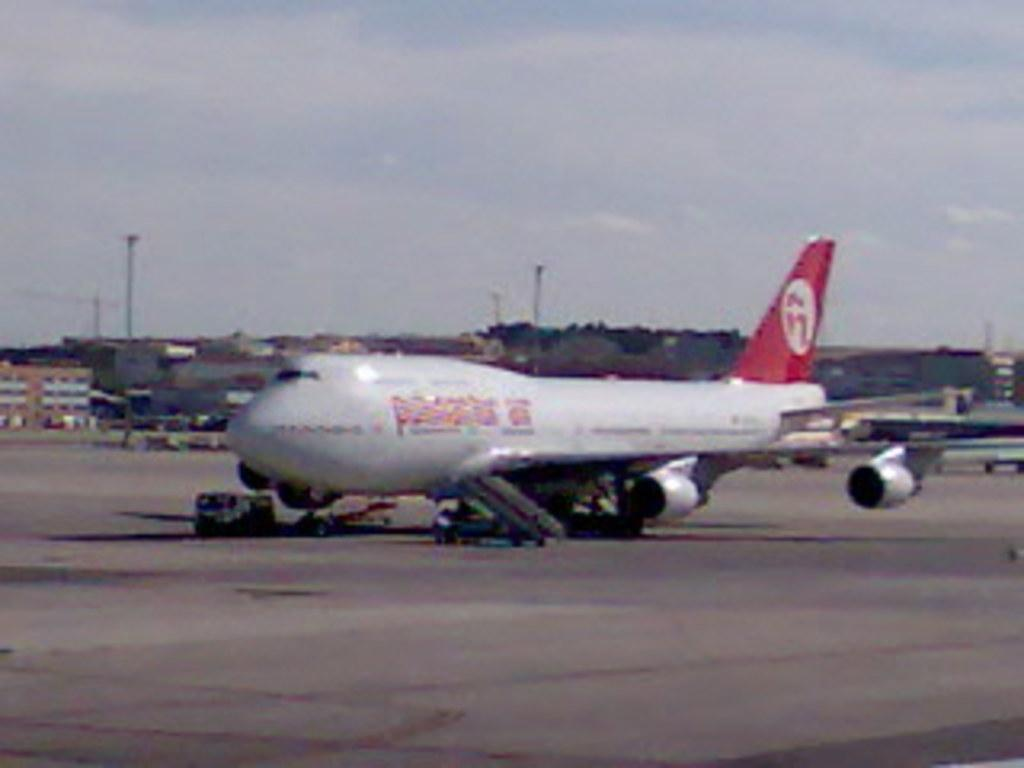What is the main subject of the image? The main subject of the image is an aircraft. Can you describe the colors of the aircraft? The aircraft is in white and red color. What can be seen in the background of the image? There are buildings, trees, and light poles in the background of the image. What is the color of the sky in the image? The sky is white in color. How many friends are sitting on the toys in the image? There are no friends or toys present in the image; it features an aircraft and a background with buildings, trees, and light poles. 